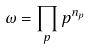<formula> <loc_0><loc_0><loc_500><loc_500>\omega = \prod _ { p } p ^ { n _ { p } }</formula> 